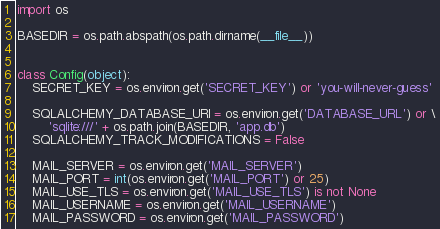<code> <loc_0><loc_0><loc_500><loc_500><_Python_>import os

BASEDIR = os.path.abspath(os.path.dirname(__file__))


class Config(object):
    SECRET_KEY = os.environ.get('SECRET_KEY') or 'you-will-never-guess'

    SQLALCHEMY_DATABASE_URI = os.environ.get('DATABASE_URL') or \
        'sqlite:///' + os.path.join(BASEDIR, 'app.db')
    SQLALCHEMY_TRACK_MODIFICATIONS = False

    MAIL_SERVER = os.environ.get('MAIL_SERVER')
    MAIL_PORT = int(os.environ.get('MAIL_PORT') or 25)
    MAIL_USE_TLS = os.environ.get('MAIL_USE_TLS') is not None
    MAIL_USERNAME = os.environ.get('MAIL_USERNAME')
    MAIL_PASSWORD = os.environ.get('MAIL_PASSWORD')</code> 